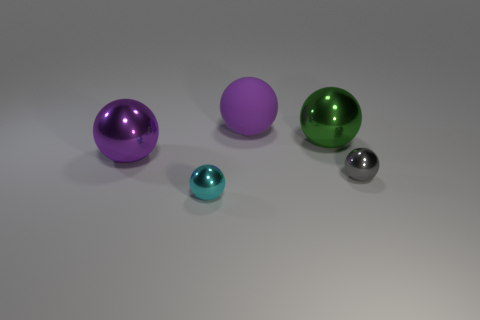Subtract 2 balls. How many balls are left? 3 Add 5 rubber things. How many objects exist? 10 Subtract 0 yellow cubes. How many objects are left? 5 Subtract all big purple rubber balls. Subtract all big metal balls. How many objects are left? 2 Add 4 small cyan metal balls. How many small cyan metal balls are left? 5 Add 3 small purple shiny cylinders. How many small purple shiny cylinders exist? 3 